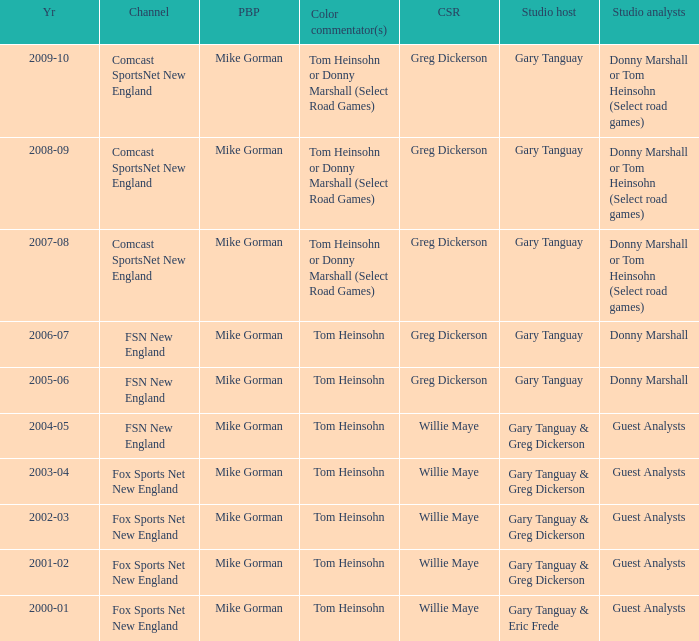WHich Color commentatorhas a Studio host of gary tanguay & eric frede? Tom Heinsohn. I'm looking to parse the entire table for insights. Could you assist me with that? {'header': ['Yr', 'Channel', 'PBP', 'Color commentator(s)', 'CSR', 'Studio host', 'Studio analysts'], 'rows': [['2009-10', 'Comcast SportsNet New England', 'Mike Gorman', 'Tom Heinsohn or Donny Marshall (Select Road Games)', 'Greg Dickerson', 'Gary Tanguay', 'Donny Marshall or Tom Heinsohn (Select road games)'], ['2008-09', 'Comcast SportsNet New England', 'Mike Gorman', 'Tom Heinsohn or Donny Marshall (Select Road Games)', 'Greg Dickerson', 'Gary Tanguay', 'Donny Marshall or Tom Heinsohn (Select road games)'], ['2007-08', 'Comcast SportsNet New England', 'Mike Gorman', 'Tom Heinsohn or Donny Marshall (Select Road Games)', 'Greg Dickerson', 'Gary Tanguay', 'Donny Marshall or Tom Heinsohn (Select road games)'], ['2006-07', 'FSN New England', 'Mike Gorman', 'Tom Heinsohn', 'Greg Dickerson', 'Gary Tanguay', 'Donny Marshall'], ['2005-06', 'FSN New England', 'Mike Gorman', 'Tom Heinsohn', 'Greg Dickerson', 'Gary Tanguay', 'Donny Marshall'], ['2004-05', 'FSN New England', 'Mike Gorman', 'Tom Heinsohn', 'Willie Maye', 'Gary Tanguay & Greg Dickerson', 'Guest Analysts'], ['2003-04', 'Fox Sports Net New England', 'Mike Gorman', 'Tom Heinsohn', 'Willie Maye', 'Gary Tanguay & Greg Dickerson', 'Guest Analysts'], ['2002-03', 'Fox Sports Net New England', 'Mike Gorman', 'Tom Heinsohn', 'Willie Maye', 'Gary Tanguay & Greg Dickerson', 'Guest Analysts'], ['2001-02', 'Fox Sports Net New England', 'Mike Gorman', 'Tom Heinsohn', 'Willie Maye', 'Gary Tanguay & Greg Dickerson', 'Guest Analysts'], ['2000-01', 'Fox Sports Net New England', 'Mike Gorman', 'Tom Heinsohn', 'Willie Maye', 'Gary Tanguay & Eric Frede', 'Guest Analysts']]} 